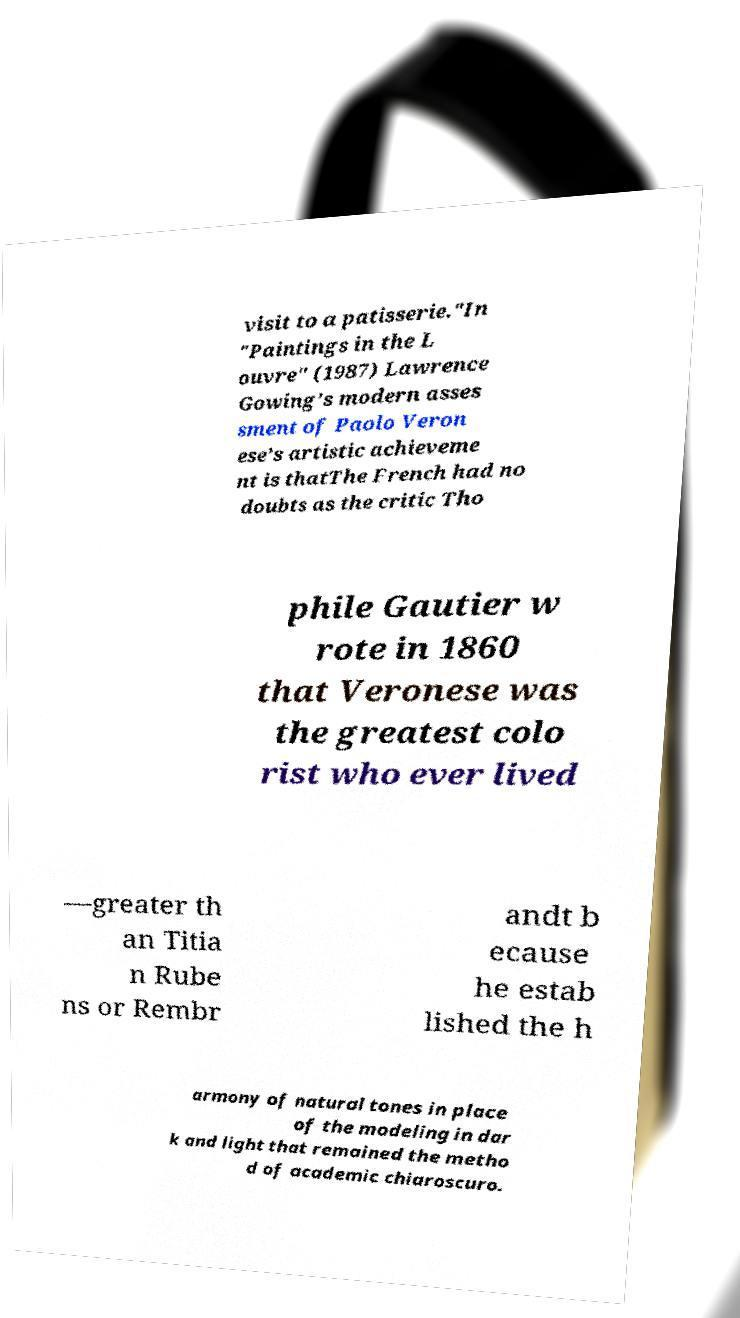There's text embedded in this image that I need extracted. Can you transcribe it verbatim? visit to a patisserie."In "Paintings in the L ouvre" (1987) Lawrence Gowing’s modern asses sment of Paolo Veron ese’s artistic achieveme nt is thatThe French had no doubts as the critic Tho phile Gautier w rote in 1860 that Veronese was the greatest colo rist who ever lived —greater th an Titia n Rube ns or Rembr andt b ecause he estab lished the h armony of natural tones in place of the modeling in dar k and light that remained the metho d of academic chiaroscuro. 